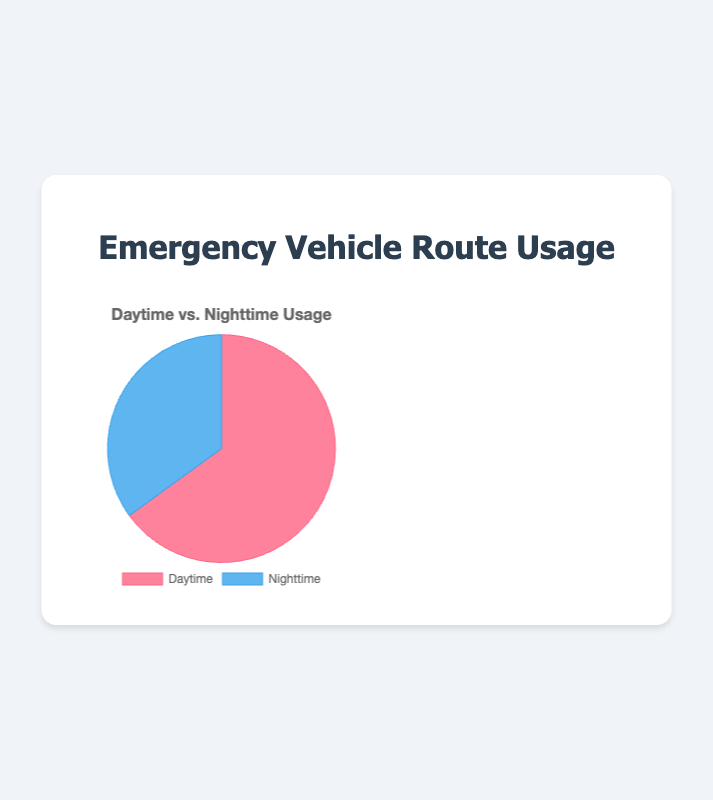What percentage of emergency vehicle route usage occurs during night time? The chart displays that 35 out of the total 100 data points are recorded for nighttime. To find the percentage: (35 / (65 + 35)) * 100 = 35%. So, nighttime usage is 35% of the total.
Answer: 35% What is the difference in emergency vehicle route usage between daytime and nighttime? The chart shows daytime usage is 65 and nighttime usage is 35. The difference is 65 - 35 = 30.
Answer: 30 Which time period sees more usage of emergency vehicle routes? The chart demonstrates that daytime usage accounts for 65 out of the total 100, whereas nighttime usage accounts for 35 out of 100. Since 65 > 35, more usage occurs during the daytime.
Answer: Daytime What fraction of the total emergency vehicle route usage is during daytime? The total usage is 65 (daytime) + 35 (nighttime) = 100. The fraction of daytime usage is 65 / 100 = 0.65.
Answer: 0.65 If the usage during nighttime increases by 15, what will be the new percentage of nighttime usage? Current nighttime usage is 35. Adding 15 gives us 35 + 15 = 50. Thus, the total usage becomes 65 (daytime) + 50 (nighttime) = 115. The new percentage for nighttime is (50 / 115) * 100 ≈ 43.48%.
Answer: 43.48% Compare the colors used in the pie chart for both daytime and nighttime. The pie chart uses a shade of red for daytime and a shade of blue for nighttime. This provides a visual contrast between the two periods.
Answer: Red for daytime, blue for nighttime What is the combined total of emergency vehicle route usage for both periods? Summing up the numbers for both periods: 65 (daytime) + 35 (nighttime) = 100.
Answer: 100 If daytime usage is reduced by 10, how many times greater will daytime usage still be compared to nighttime? Reducing daytime usage by 10 gives 65 - 10 = 55. Now, compare 55 (daytime) to 35 (nighttime): 55 / 35 ≈ 1.57 times.
Answer: 1.57 times 